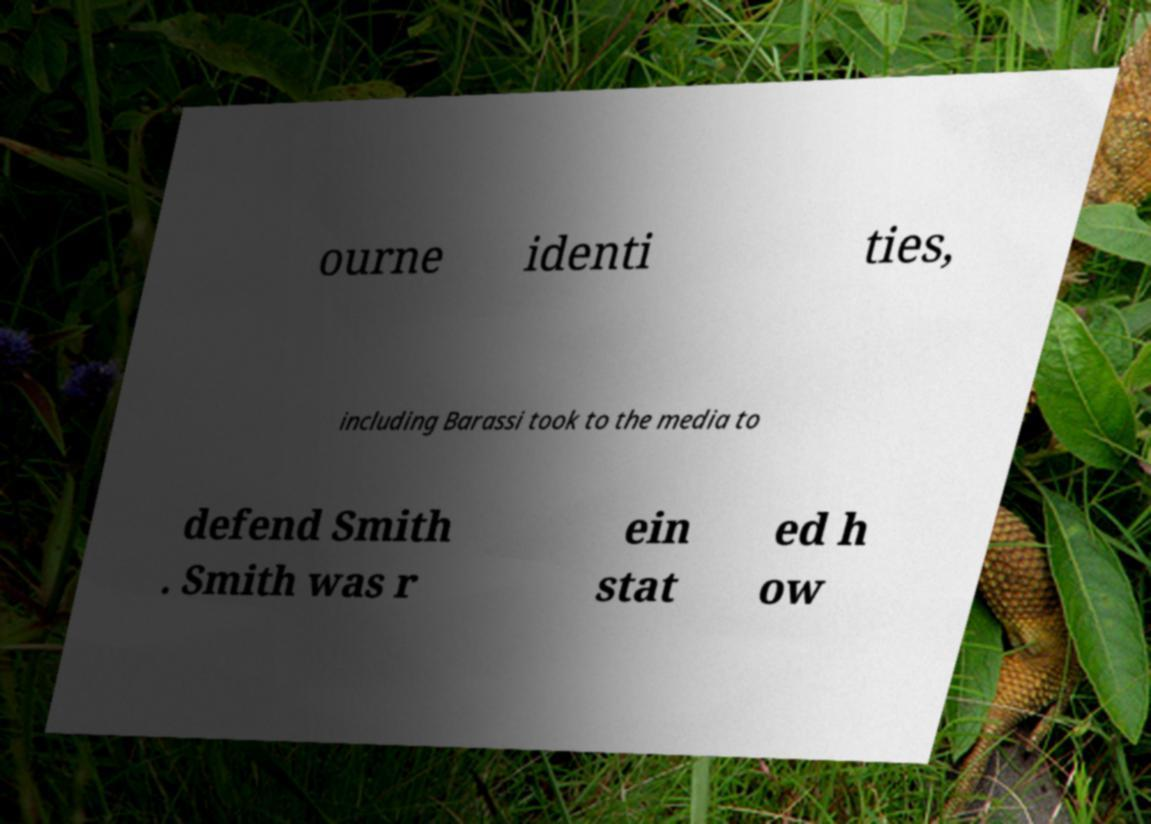Can you read and provide the text displayed in the image?This photo seems to have some interesting text. Can you extract and type it out for me? ourne identi ties, including Barassi took to the media to defend Smith . Smith was r ein stat ed h ow 